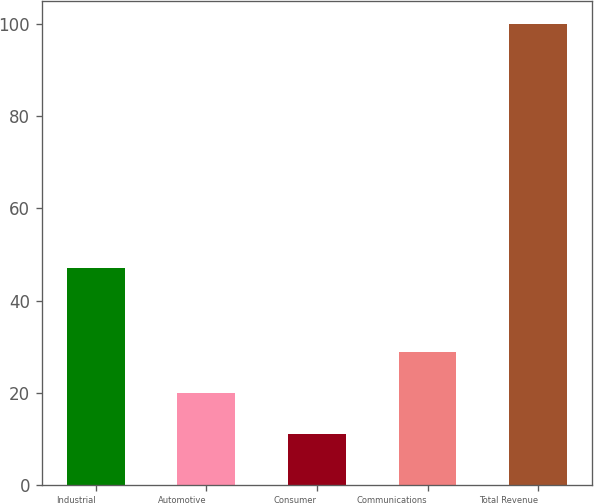Convert chart to OTSL. <chart><loc_0><loc_0><loc_500><loc_500><bar_chart><fcel>Industrial<fcel>Automotive<fcel>Consumer<fcel>Communications<fcel>Total Revenue<nl><fcel>47<fcel>19.9<fcel>11<fcel>28.8<fcel>100<nl></chart> 